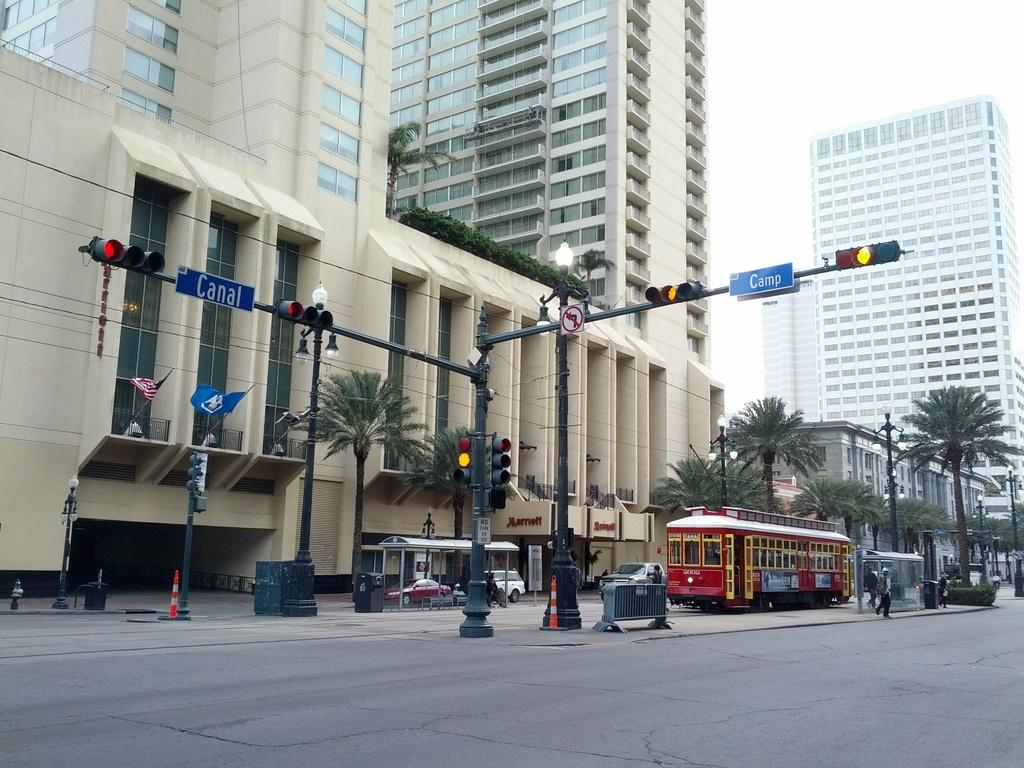<image>
Relay a brief, clear account of the picture shown. A red trolley at the intersection of Canal and Camp street. 